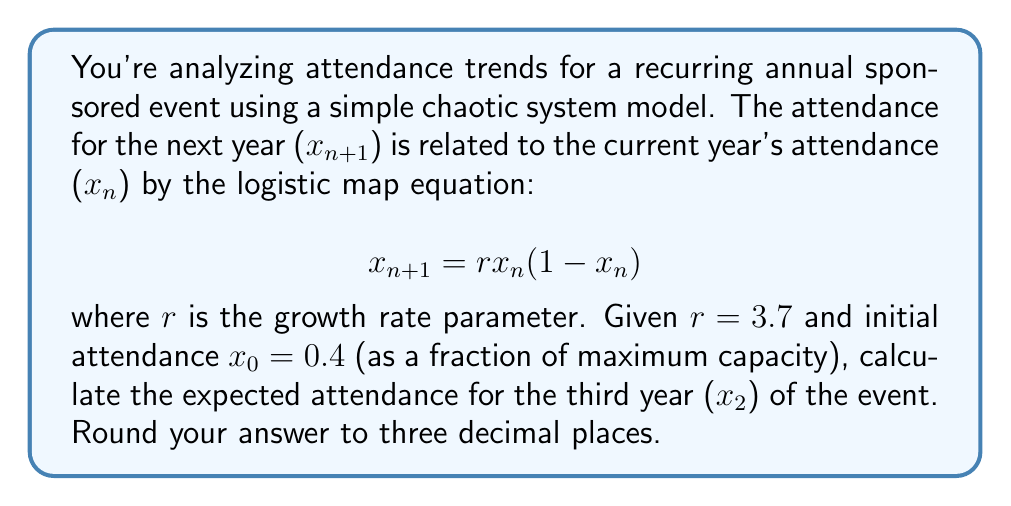Solve this math problem. To solve this problem, we need to iterate the logistic map equation twice, starting from the initial condition. Let's go through this step-by-step:

1) We are given:
   $r = 3.7$
   $x_0 = 0.4$

2) First, let's calculate $x_1$ (attendance for the first year):
   $$x_1 = rx_0(1-x_0)$$
   $$x_1 = 3.7 \cdot 0.4 \cdot (1-0.4)$$
   $$x_1 = 3.7 \cdot 0.4 \cdot 0.6$$
   $$x_1 = 0.888$$

3) Now, we use this value of $x_1$ to calculate $x_2$ (attendance for the second year):
   $$x_2 = rx_1(1-x_1)$$
   $$x_2 = 3.7 \cdot 0.888 \cdot (1-0.888)$$
   $$x_2 = 3.7 \cdot 0.888 \cdot 0.112$$
   $$x_2 = 0.368$$

4) Rounding to three decimal places:
   $$x_2 \approx 0.368$$

This value represents the expected attendance for the third year as a fraction of the maximum capacity.
Answer: 0.368 